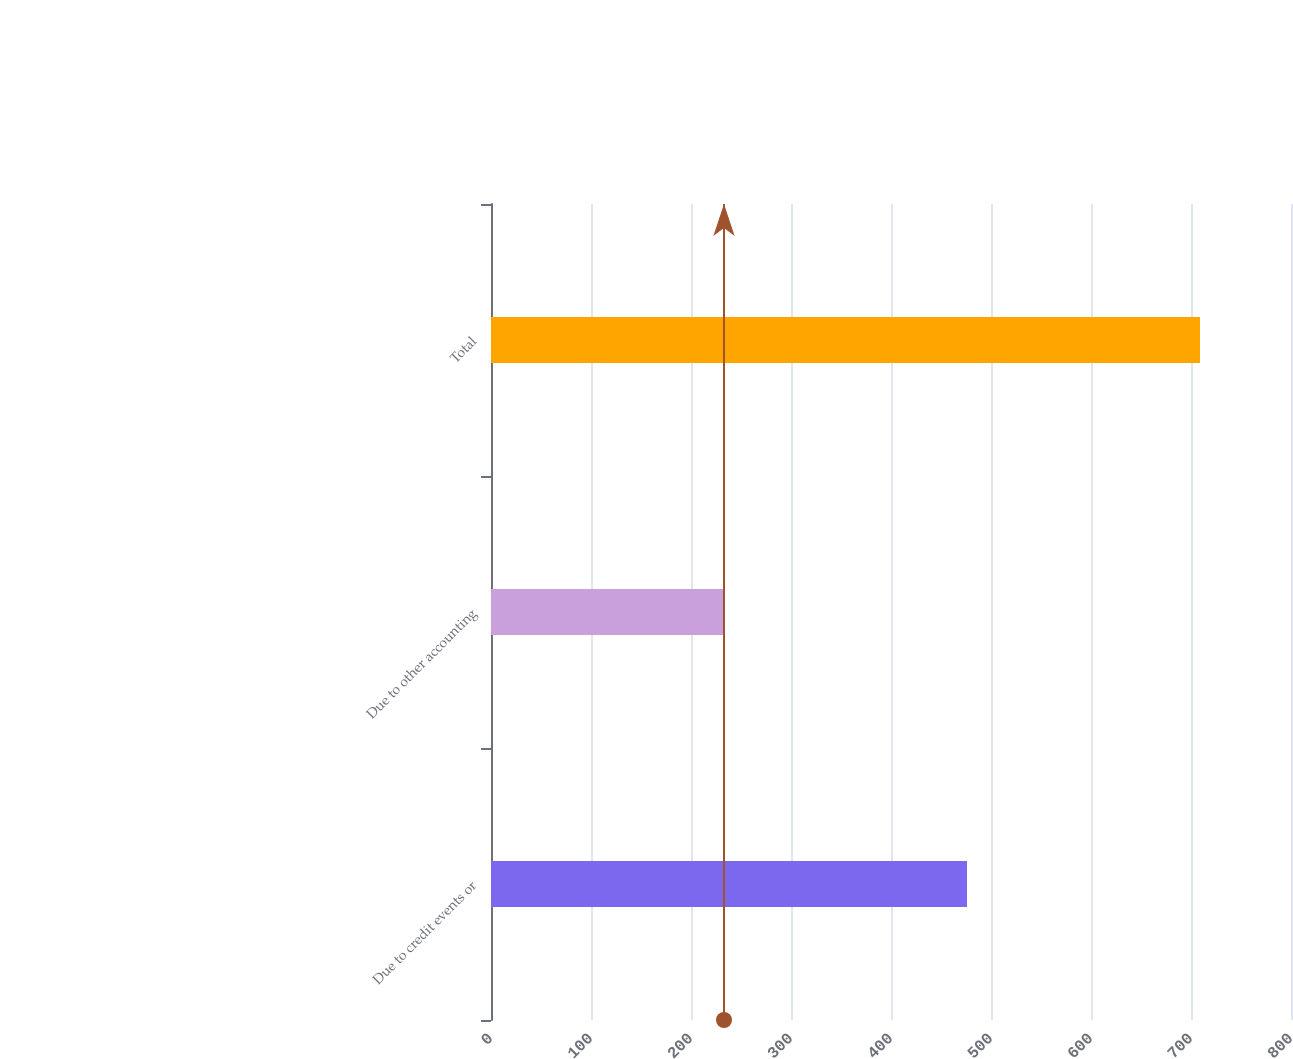<chart> <loc_0><loc_0><loc_500><loc_500><bar_chart><fcel>Due to credit events or<fcel>Due to other accounting<fcel>Total<nl><fcel>476<fcel>233<fcel>709<nl></chart> 